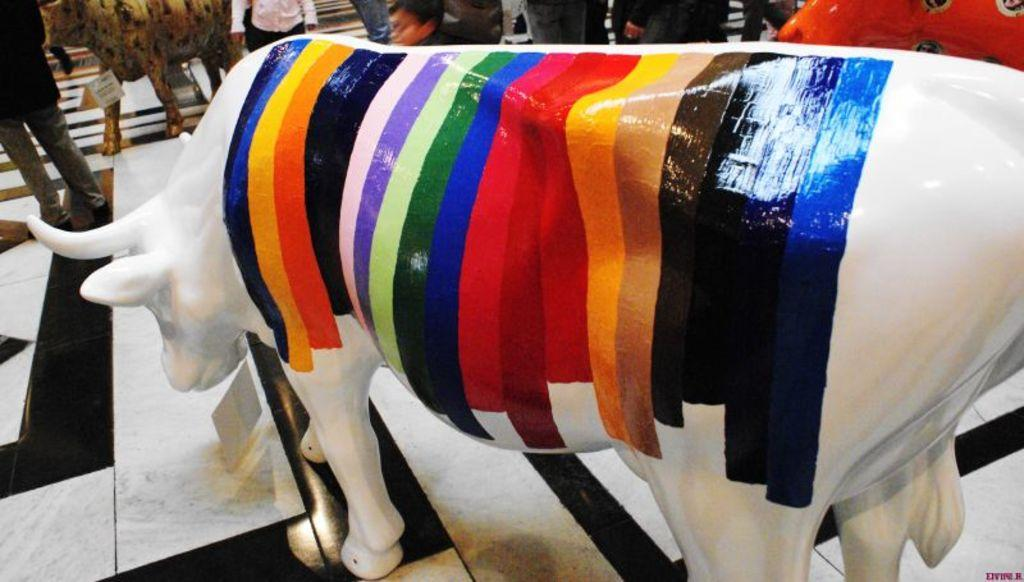What is the main subject in the image? There is a statue in the image. What else can be seen in the background of the image? There are people standing in the background of the image. What is visible at the bottom of the image? The floor is visible at the bottom of the image. How many brothers are depicted in the image? There are no brothers depicted in the image; it features a statue and people in the background. What type of scarf is wrapped around the statue's neck in the image? There is no scarf present in the image; it features a statue and people in the background. 